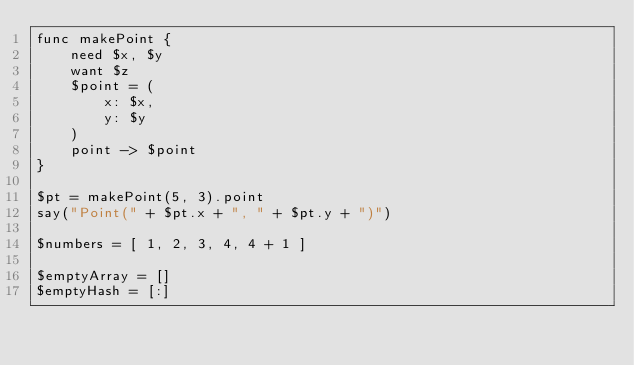Convert code to text. <code><loc_0><loc_0><loc_500><loc_500><_Forth_>func makePoint {
    need $x, $y
    want $z
    $point = (
        x: $x,
        y: $y
    )
    point -> $point
}

$pt = makePoint(5, 3).point
say("Point(" + $pt.x + ", " + $pt.y + ")")

$numbers = [ 1, 2, 3, 4, 4 + 1 ]

$emptyArray = []
$emptyHash = [:]
</code> 